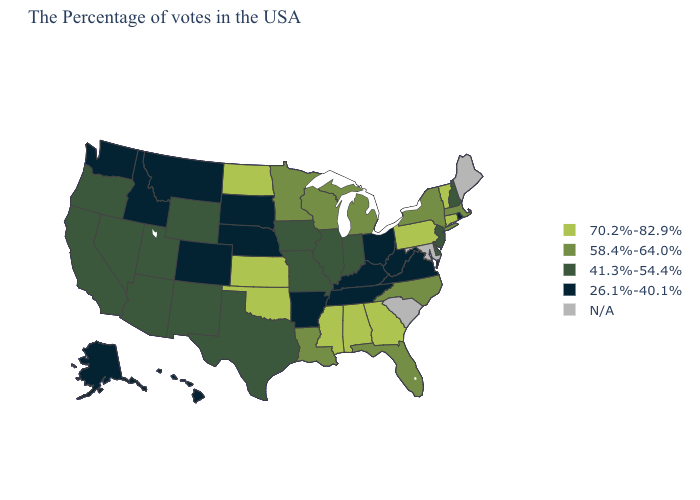What is the highest value in the USA?
Write a very short answer. 70.2%-82.9%. Name the states that have a value in the range 41.3%-54.4%?
Give a very brief answer. New Hampshire, New Jersey, Delaware, Indiana, Illinois, Missouri, Iowa, Texas, Wyoming, New Mexico, Utah, Arizona, Nevada, California, Oregon. Name the states that have a value in the range 41.3%-54.4%?
Quick response, please. New Hampshire, New Jersey, Delaware, Indiana, Illinois, Missouri, Iowa, Texas, Wyoming, New Mexico, Utah, Arizona, Nevada, California, Oregon. Name the states that have a value in the range 70.2%-82.9%?
Give a very brief answer. Vermont, Connecticut, Pennsylvania, Georgia, Alabama, Mississippi, Kansas, Oklahoma, North Dakota. Does the map have missing data?
Answer briefly. Yes. What is the value of Maine?
Quick response, please. N/A. Which states have the lowest value in the USA?
Write a very short answer. Rhode Island, Virginia, West Virginia, Ohio, Kentucky, Tennessee, Arkansas, Nebraska, South Dakota, Colorado, Montana, Idaho, Washington, Alaska, Hawaii. Name the states that have a value in the range 70.2%-82.9%?
Concise answer only. Vermont, Connecticut, Pennsylvania, Georgia, Alabama, Mississippi, Kansas, Oklahoma, North Dakota. What is the lowest value in states that border Idaho?
Give a very brief answer. 26.1%-40.1%. Which states have the highest value in the USA?
Answer briefly. Vermont, Connecticut, Pennsylvania, Georgia, Alabama, Mississippi, Kansas, Oklahoma, North Dakota. What is the value of Arizona?
Write a very short answer. 41.3%-54.4%. What is the value of North Dakota?
Be succinct. 70.2%-82.9%. Among the states that border Delaware , does New Jersey have the highest value?
Quick response, please. No. Does Ohio have the lowest value in the MidWest?
Write a very short answer. Yes. Among the states that border Ohio , does West Virginia have the highest value?
Quick response, please. No. 